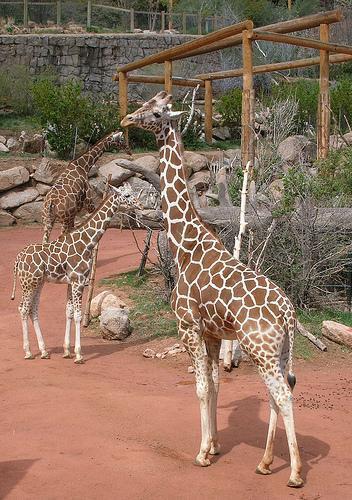How many animals are there?
Give a very brief answer. 3. 